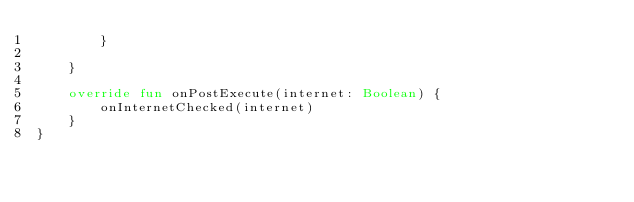Convert code to text. <code><loc_0><loc_0><loc_500><loc_500><_Kotlin_>        }

    }

    override fun onPostExecute(internet: Boolean) {
        onInternetChecked(internet)
    }
}</code> 